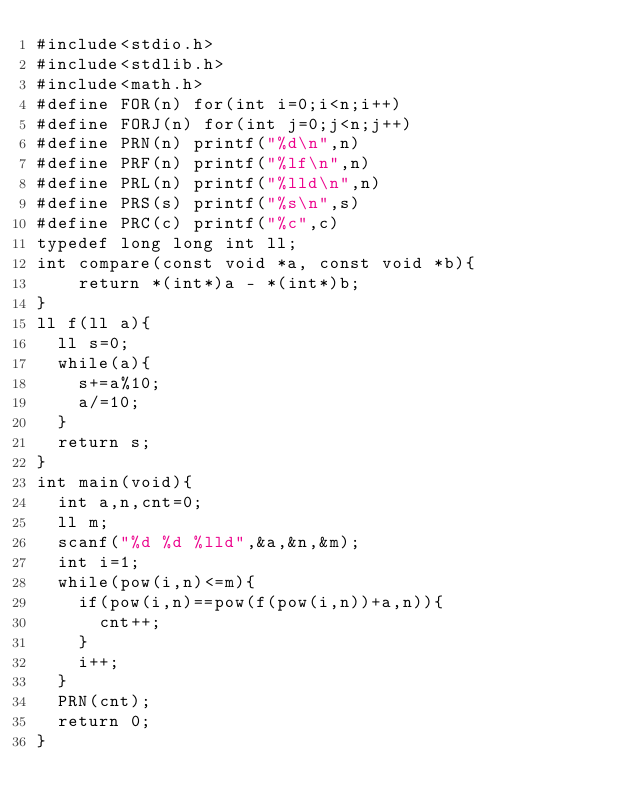<code> <loc_0><loc_0><loc_500><loc_500><_C_>#include<stdio.h>
#include<stdlib.h>
#include<math.h>
#define FOR(n) for(int i=0;i<n;i++)
#define FORJ(n) for(int j=0;j<n;j++)
#define PRN(n) printf("%d\n",n)
#define PRF(n) printf("%lf\n",n)
#define PRL(n) printf("%lld\n",n)
#define PRS(s) printf("%s\n",s)
#define PRC(c) printf("%c",c)
typedef long long int ll;
int compare(const void *a, const void *b){
    return *(int*)a - *(int*)b;
}
ll f(ll a){
  ll s=0;
  while(a){
    s+=a%10;
    a/=10;
  }
  return s;
}
int main(void){
  int a,n,cnt=0;
  ll m;
  scanf("%d %d %lld",&a,&n,&m);
  int i=1;
  while(pow(i,n)<=m){
    if(pow(i,n)==pow(f(pow(i,n))+a,n)){
      cnt++;
    }
    i++;
  }
  PRN(cnt);
  return 0;
}
</code> 